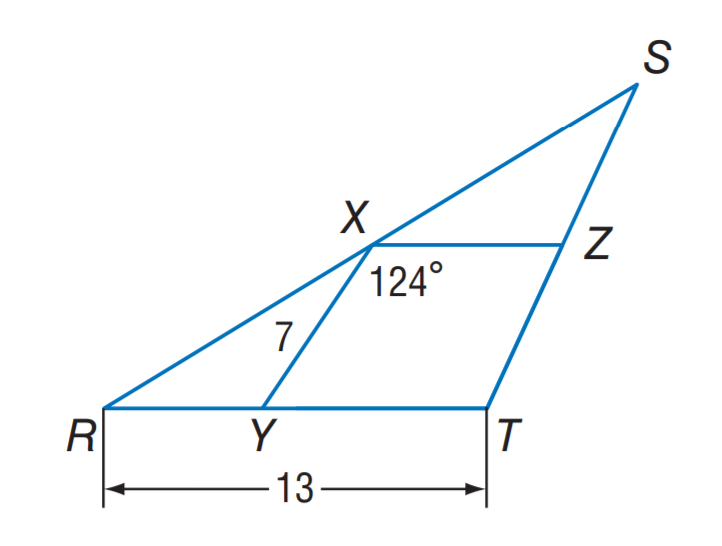Answer the mathemtical geometry problem and directly provide the correct option letter.
Question: X Y and X Z are midsegments of \triangle R S T. Find X Z.
Choices: A: 5 B: 6.5 C: 7 D: 13 B 